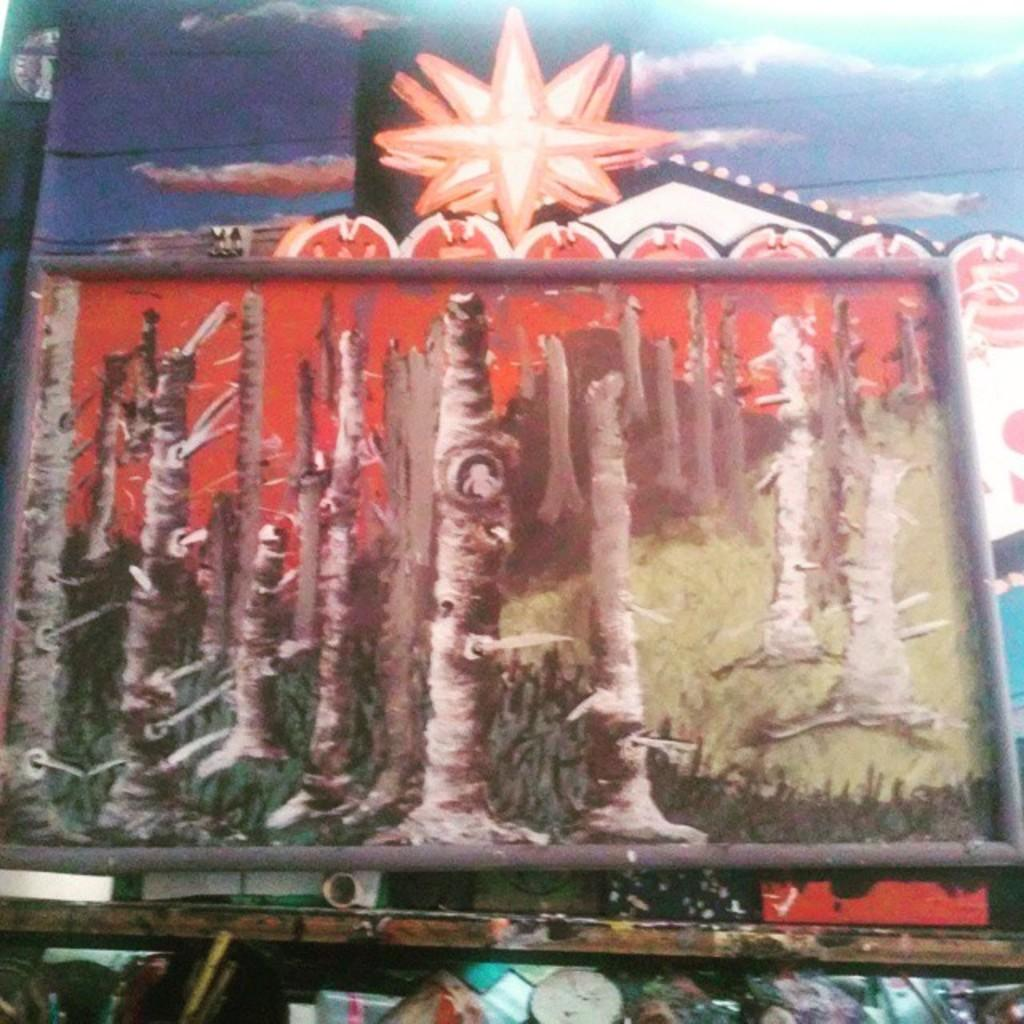What objects can be seen in the image? There are boards in the image. What can be seen on the wall in the background of the image? There is a painting on the wall in the background of the image. What page is the writer working on in the image? There is no writer or page present in the image; it only features boards and a painting on the wall. 